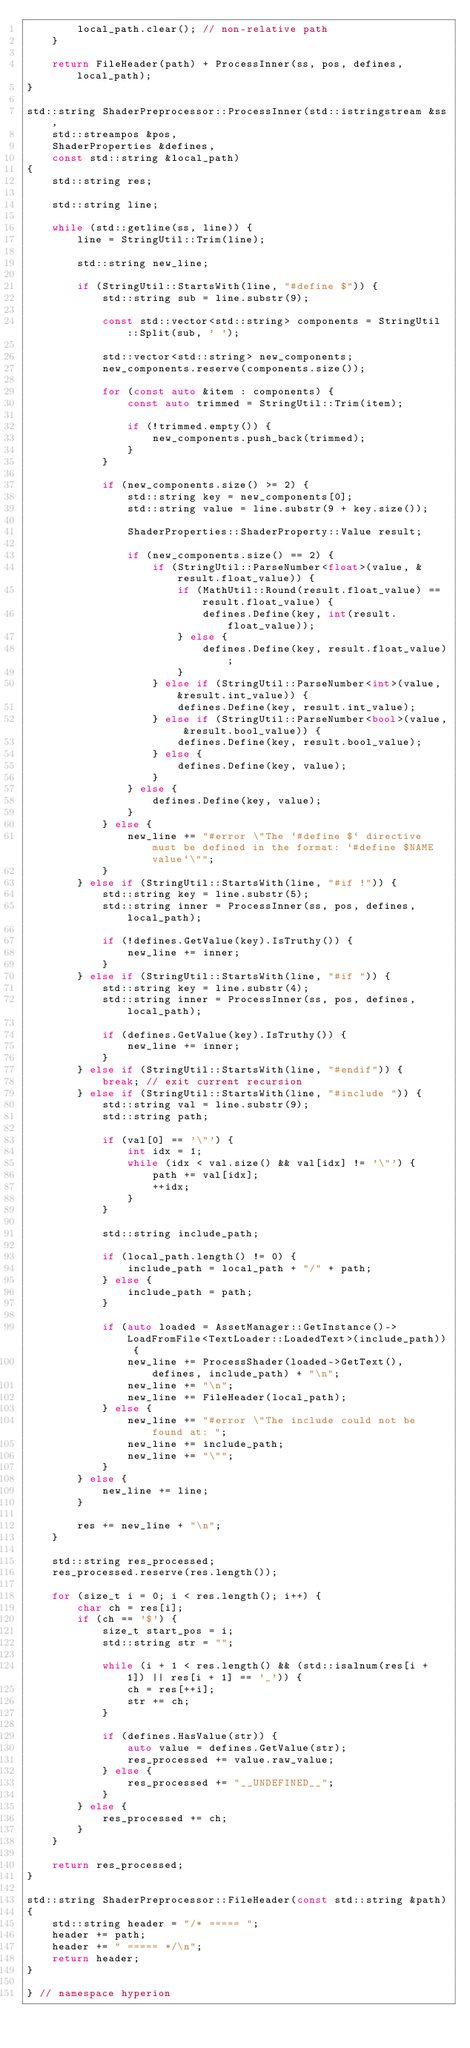Convert code to text. <code><loc_0><loc_0><loc_500><loc_500><_C++_>        local_path.clear(); // non-relative path
    }

    return FileHeader(path) + ProcessInner(ss, pos, defines, local_path);
}

std::string ShaderPreprocessor::ProcessInner(std::istringstream &ss, 
    std::streampos &pos,
    ShaderProperties &defines,
    const std::string &local_path)
{
    std::string res;

    std::string line;

    while (std::getline(ss, line)) {
        line = StringUtil::Trim(line);

        std::string new_line;

        if (StringUtil::StartsWith(line, "#define $")) {
            std::string sub = line.substr(9);

            const std::vector<std::string> components = StringUtil::Split(sub, ' ');

            std::vector<std::string> new_components;
            new_components.reserve(components.size());

            for (const auto &item : components) {
                const auto trimmed = StringUtil::Trim(item);

                if (!trimmed.empty()) {
                    new_components.push_back(trimmed);
                }
            }

            if (new_components.size() >= 2) {
                std::string key = new_components[0];
                std::string value = line.substr(9 + key.size());

                ShaderProperties::ShaderProperty::Value result;

                if (new_components.size() == 2) {
                    if (StringUtil::ParseNumber<float>(value, &result.float_value)) {
                        if (MathUtil::Round(result.float_value) == result.float_value) {
                            defines.Define(key, int(result.float_value));
                        } else {
                            defines.Define(key, result.float_value);
                        }
                    } else if (StringUtil::ParseNumber<int>(value, &result.int_value)) {
                        defines.Define(key, result.int_value);
                    } else if (StringUtil::ParseNumber<bool>(value, &result.bool_value)) {
                        defines.Define(key, result.bool_value);
                    } else {
                        defines.Define(key, value);
                    }
                } else {
                    defines.Define(key, value);
                }
            } else {
                new_line += "#error \"The `#define $` directive must be defined in the format: `#define $NAME value`\"";
            }
        } else if (StringUtil::StartsWith(line, "#if !")) {
            std::string key = line.substr(5);
            std::string inner = ProcessInner(ss, pos, defines, local_path);

            if (!defines.GetValue(key).IsTruthy()) {
                new_line += inner;
            }
        } else if (StringUtil::StartsWith(line, "#if ")) {
            std::string key = line.substr(4);
            std::string inner = ProcessInner(ss, pos, defines, local_path);

            if (defines.GetValue(key).IsTruthy()) {
                new_line += inner;
            }
        } else if (StringUtil::StartsWith(line, "#endif")) {
            break; // exit current recursion
        } else if (StringUtil::StartsWith(line, "#include ")) {
            std::string val = line.substr(9);
            std::string path;

            if (val[0] == '\"') {
                int idx = 1;
                while (idx < val.size() && val[idx] != '\"') {
                    path += val[idx];
                    ++idx;
                }
            }

            std::string include_path;
            
            if (local_path.length() != 0) {
                include_path = local_path + "/" + path;
            } else {
                include_path = path;
            }

            if (auto loaded = AssetManager::GetInstance()->LoadFromFile<TextLoader::LoadedText>(include_path)) {
                new_line += ProcessShader(loaded->GetText(), defines, include_path) + "\n";
                new_line += "\n";
                new_line += FileHeader(local_path);
            } else {
                new_line += "#error \"The include could not be found at: ";
                new_line += include_path;
                new_line += "\"";
            }
        } else {
            new_line += line;
        }

        res += new_line + "\n";
    }

    std::string res_processed;
    res_processed.reserve(res.length());

    for (size_t i = 0; i < res.length(); i++) {
        char ch = res[i];
        if (ch == '$') {
            size_t start_pos = i;
            std::string str = "";

            while (i + 1 < res.length() && (std::isalnum(res[i + 1]) || res[i + 1] == '_')) {
                ch = res[++i];
                str += ch;
            }

            if (defines.HasValue(str)) {
                auto value = defines.GetValue(str);
                res_processed += value.raw_value;
            } else {
                res_processed += "__UNDEFINED__";
            }
        } else {
            res_processed += ch;
        }
    }

    return res_processed;
}

std::string ShaderPreprocessor::FileHeader(const std::string &path)
{
    std::string header = "/* ===== ";
    header += path;
    header += " ===== */\n";
    return header;
}

} // namespace hyperion
</code> 